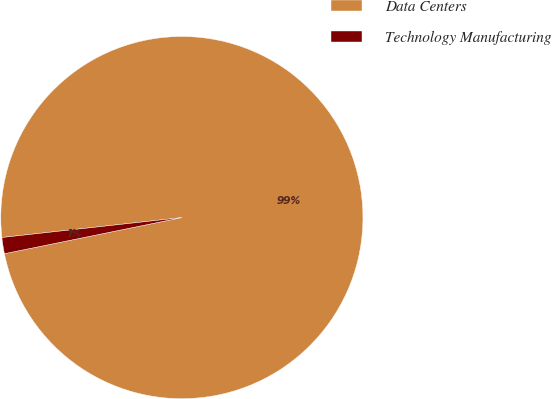Convert chart. <chart><loc_0><loc_0><loc_500><loc_500><pie_chart><fcel>Data Centers<fcel>Technology Manufacturing<nl><fcel>98.56%<fcel>1.44%<nl></chart> 